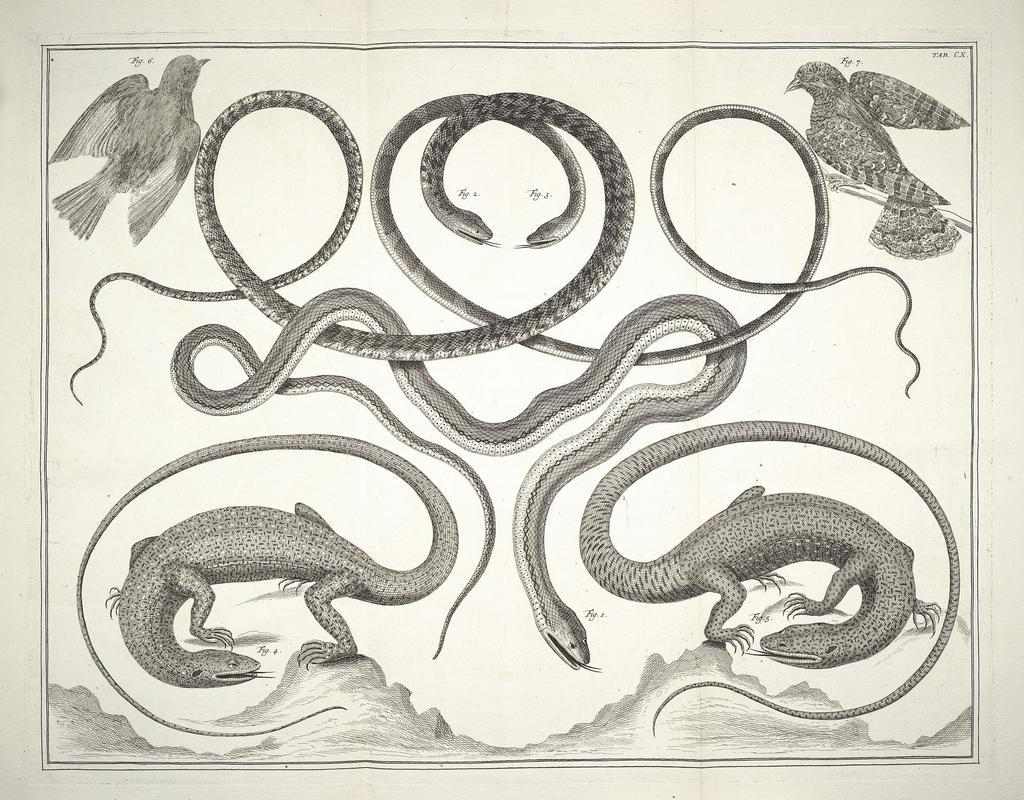What type of visual is the image? The image is a poster. What animals are depicted on the poster? There are snakes, lizards, and birds depicted on the poster. How many children are playing with the shoe in the image? There are no children or shoes present in the image; it features a poster with snakes, lizards, and birds. 